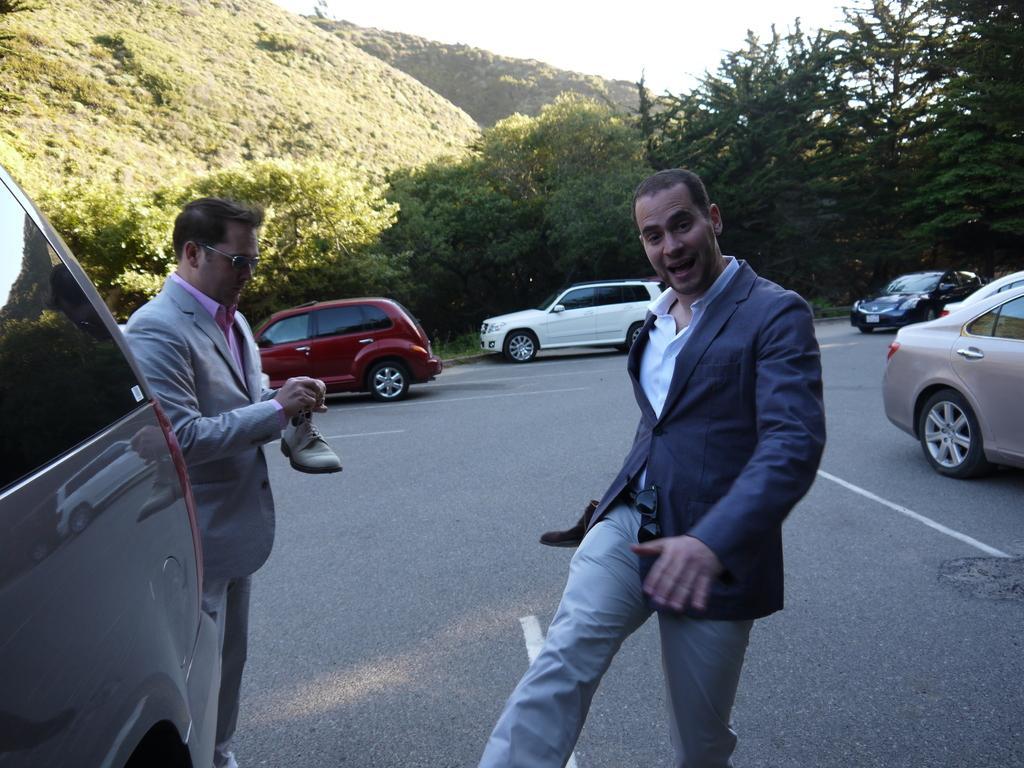In one or two sentences, can you explain what this image depicts? In this picture we can see two men are standing in the front, there are some cars on the road, in the background we can see trees and a hill, there is the sky at the top of the picture, a man on the left side is holding a shoe. 